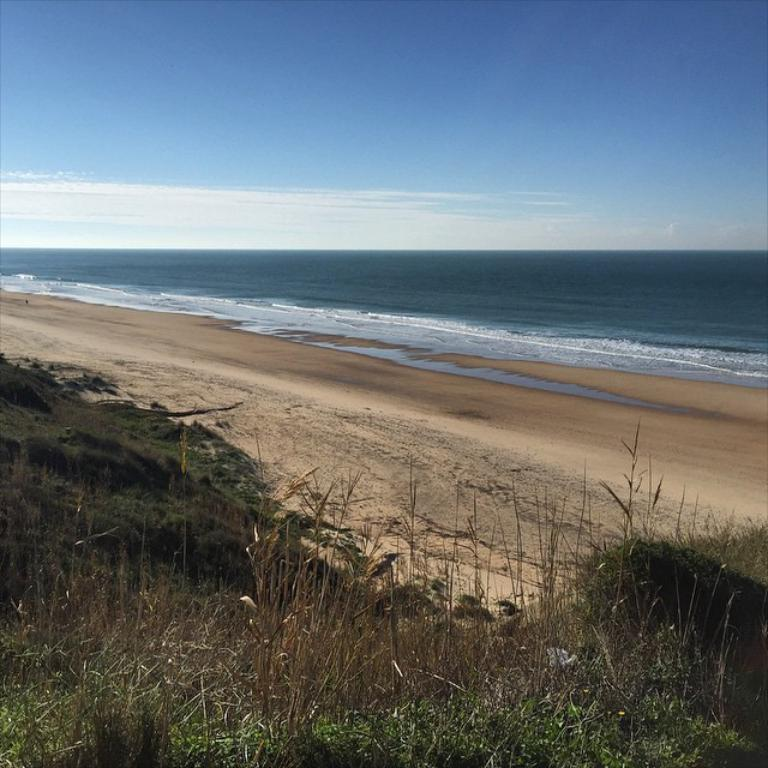What type of vegetation can be seen in the image? There is grass and plants in the image. What is the surface on which the vegetation is growing? The ground is visible in the image. What else can be seen in the image besides vegetation? There is water in the image. What is visible in the background of the image? The sky is visible in the background of the image. What type of destruction is being caused by the army in the image? There is no army or destruction present in the image; it features grass, plants, ground, water, and the sky. What type of pot is visible in the image? There is no pot present in the image. 